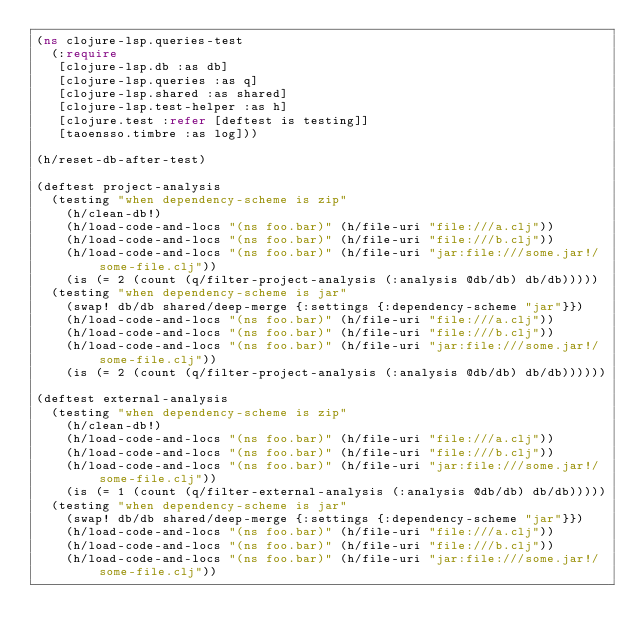Convert code to text. <code><loc_0><loc_0><loc_500><loc_500><_Clojure_>(ns clojure-lsp.queries-test
  (:require
   [clojure-lsp.db :as db]
   [clojure-lsp.queries :as q]
   [clojure-lsp.shared :as shared]
   [clojure-lsp.test-helper :as h]
   [clojure.test :refer [deftest is testing]]
   [taoensso.timbre :as log]))

(h/reset-db-after-test)

(deftest project-analysis
  (testing "when dependency-scheme is zip"
    (h/clean-db!)
    (h/load-code-and-locs "(ns foo.bar)" (h/file-uri "file:///a.clj"))
    (h/load-code-and-locs "(ns foo.bar)" (h/file-uri "file:///b.clj"))
    (h/load-code-and-locs "(ns foo.bar)" (h/file-uri "jar:file:///some.jar!/some-file.clj"))
    (is (= 2 (count (q/filter-project-analysis (:analysis @db/db) db/db)))))
  (testing "when dependency-scheme is jar"
    (swap! db/db shared/deep-merge {:settings {:dependency-scheme "jar"}})
    (h/load-code-and-locs "(ns foo.bar)" (h/file-uri "file:///a.clj"))
    (h/load-code-and-locs "(ns foo.bar)" (h/file-uri "file:///b.clj"))
    (h/load-code-and-locs "(ns foo.bar)" (h/file-uri "jar:file:///some.jar!/some-file.clj"))
    (is (= 2 (count (q/filter-project-analysis (:analysis @db/db) db/db))))))

(deftest external-analysis
  (testing "when dependency-scheme is zip"
    (h/clean-db!)
    (h/load-code-and-locs "(ns foo.bar)" (h/file-uri "file:///a.clj"))
    (h/load-code-and-locs "(ns foo.bar)" (h/file-uri "file:///b.clj"))
    (h/load-code-and-locs "(ns foo.bar)" (h/file-uri "jar:file:///some.jar!/some-file.clj"))
    (is (= 1 (count (q/filter-external-analysis (:analysis @db/db) db/db)))))
  (testing "when dependency-scheme is jar"
    (swap! db/db shared/deep-merge {:settings {:dependency-scheme "jar"}})
    (h/load-code-and-locs "(ns foo.bar)" (h/file-uri "file:///a.clj"))
    (h/load-code-and-locs "(ns foo.bar)" (h/file-uri "file:///b.clj"))
    (h/load-code-and-locs "(ns foo.bar)" (h/file-uri "jar:file:///some.jar!/some-file.clj"))</code> 